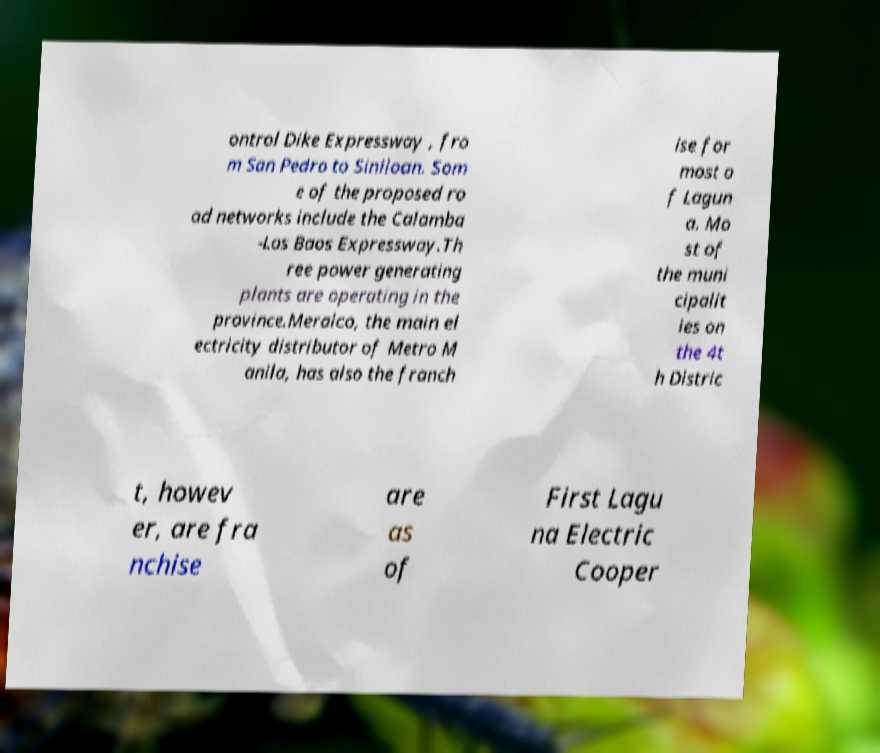Please identify and transcribe the text found in this image. ontrol Dike Expressway , fro m San Pedro to Siniloan. Som e of the proposed ro ad networks include the Calamba -Los Baos Expressway.Th ree power generating plants are operating in the province.Meralco, the main el ectricity distributor of Metro M anila, has also the franch ise for most o f Lagun a. Mo st of the muni cipalit ies on the 4t h Distric t, howev er, are fra nchise are as of First Lagu na Electric Cooper 